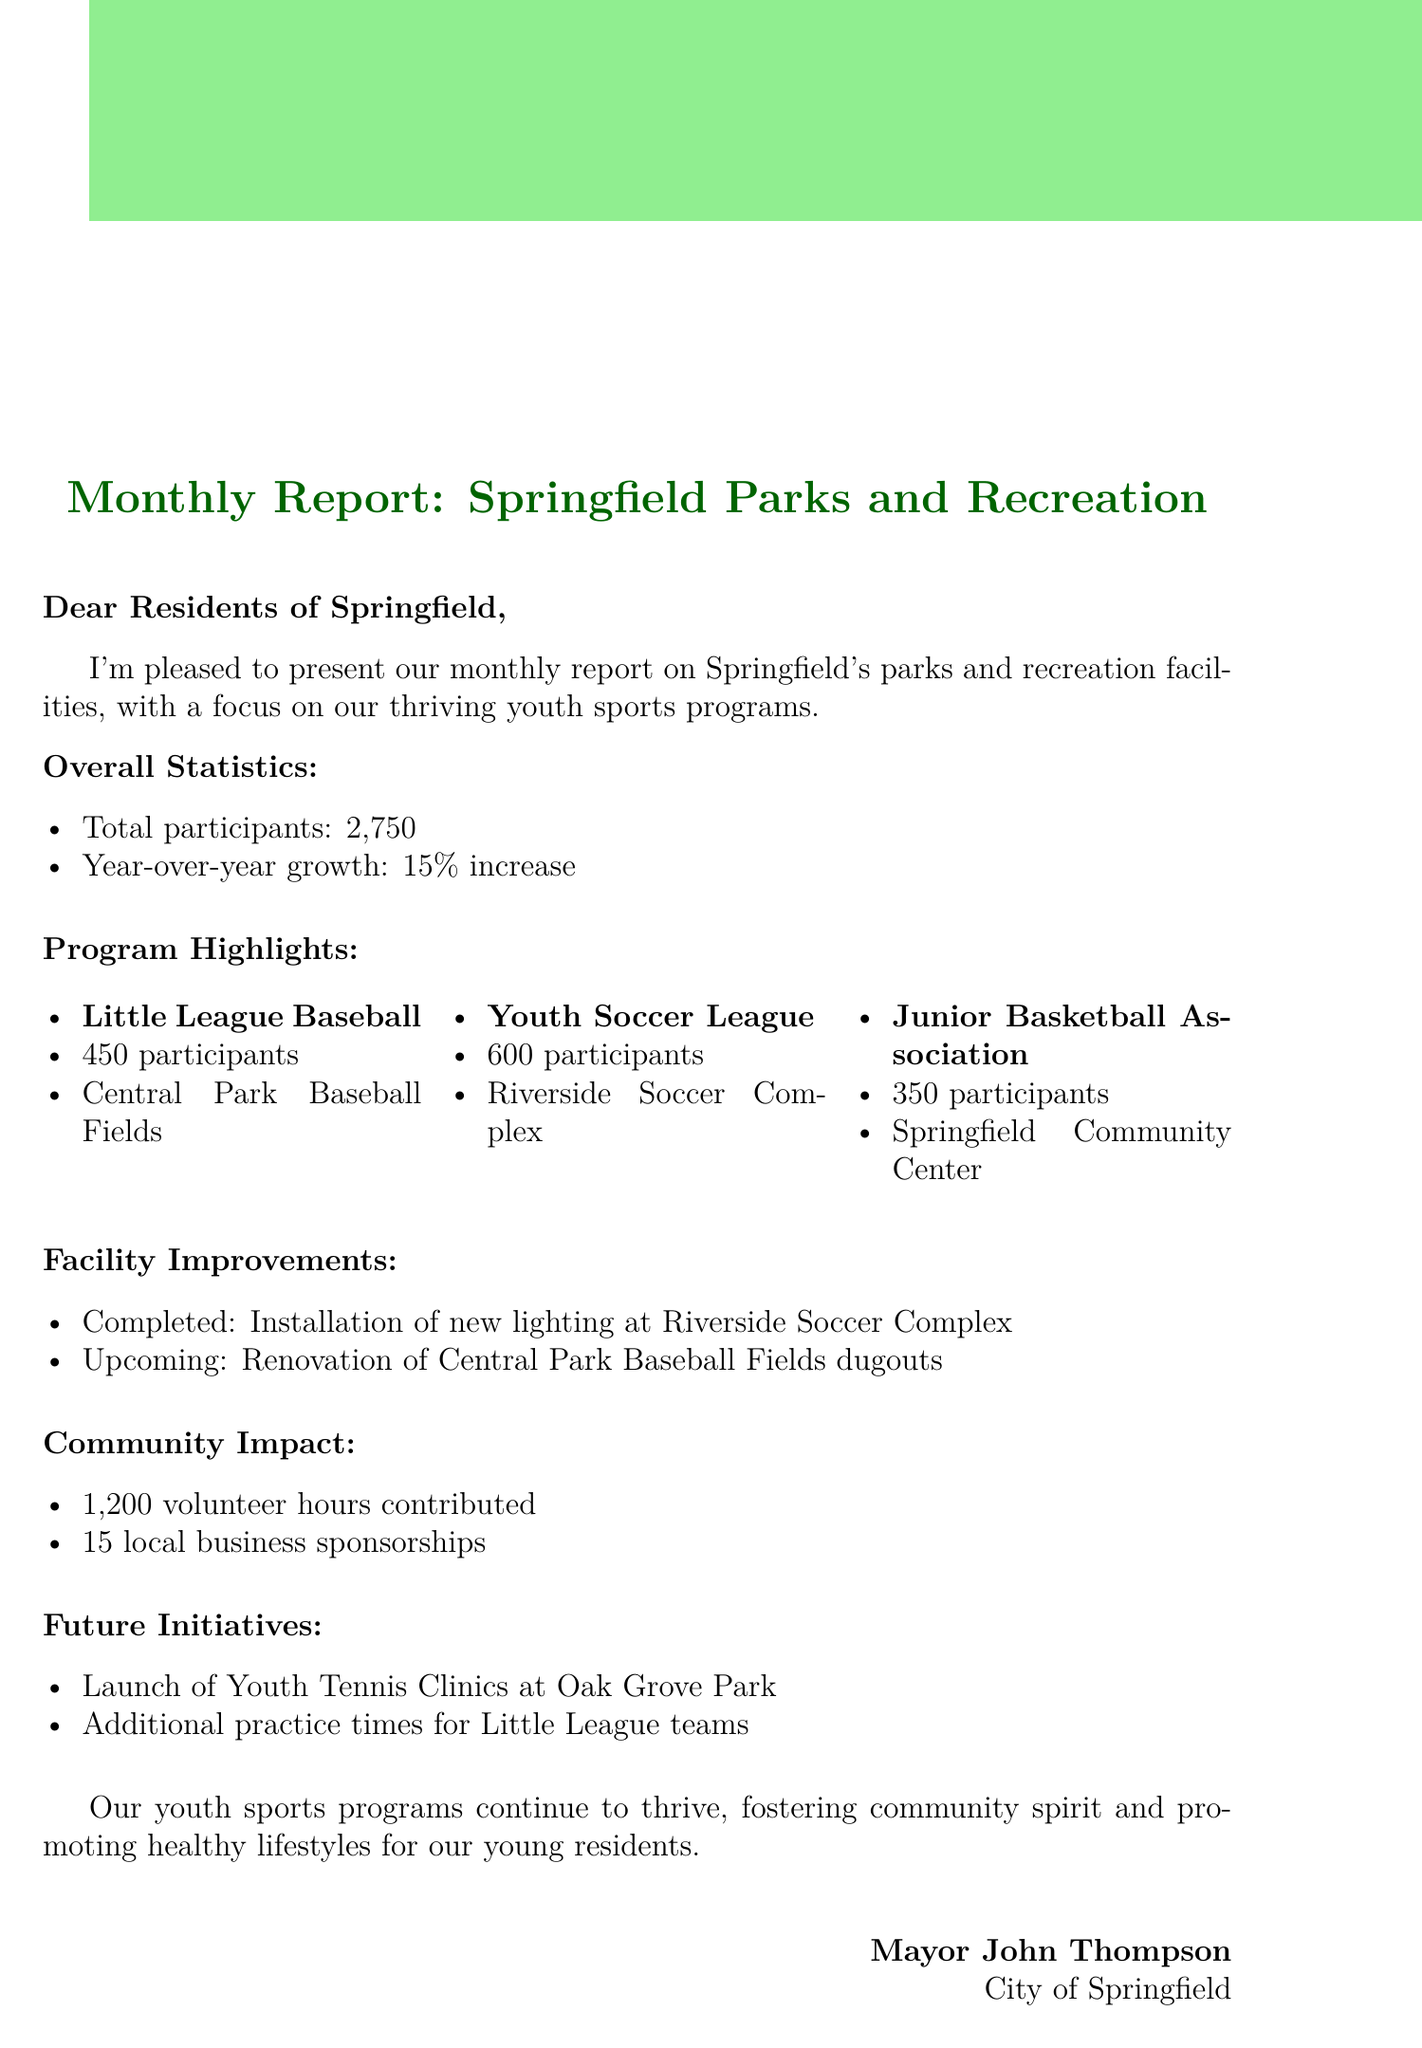What is the total number of participants in youth sports programs? The total number of participants is given in the overall statistics section of the document.
Answer: 2750 What percentage increase in youth sports program participants was reported? The document states the year-over-year growth percentage under overall statistics.
Answer: 15% How many participants are in the Youth Soccer League? The number of participants in the Youth Soccer League is specified in the program highlights section.
Answer: 600 What facility improvement was completed at the Riverside Soccer Complex? The completed improvement is mentioned in the facility improvements section of the document.
Answer: Installation of new lighting What is the name of the new program being launched? The document details future initiatives, including the name of the new program.
Answer: Youth Tennis Clinics How many volunteer hours were contributed to youth sports programs? The number of volunteer hours is indicated under community impact in the document.
Answer: 1200 Where is the Junior Basketball Association located? The location of the Junior Basketball Association is outlined in the program highlights section of the document.
Answer: Springfield Community Center What future initiative involves additional practice times? The future initiatives section mentions specific upcoming enhancements, including this one.
Answer: Additional practice times for Little League teams Who signed the document as Mayor? The signature section of the document specifies the individual who signed it.
Answer: Mayor John Thompson 